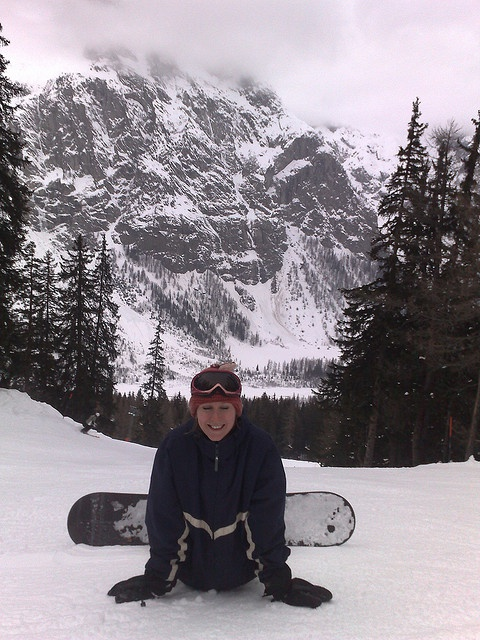Describe the objects in this image and their specific colors. I can see people in lavender, black, gray, lightgray, and darkgray tones, snowboard in lavender, darkgray, black, and gray tones, and people in lavender, black, gray, and darkgray tones in this image. 